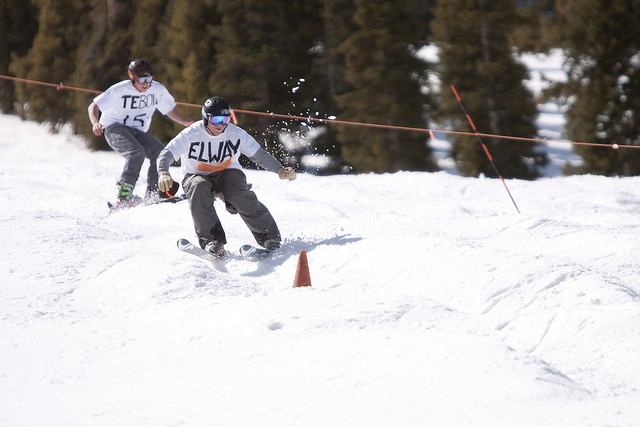Describe the objects in this image and their specific colors. I can see people in black, gray, lavender, and darkgray tones, people in black, lavender, gray, and darkgray tones, and skis in black, lightgray, darkgray, and gray tones in this image. 